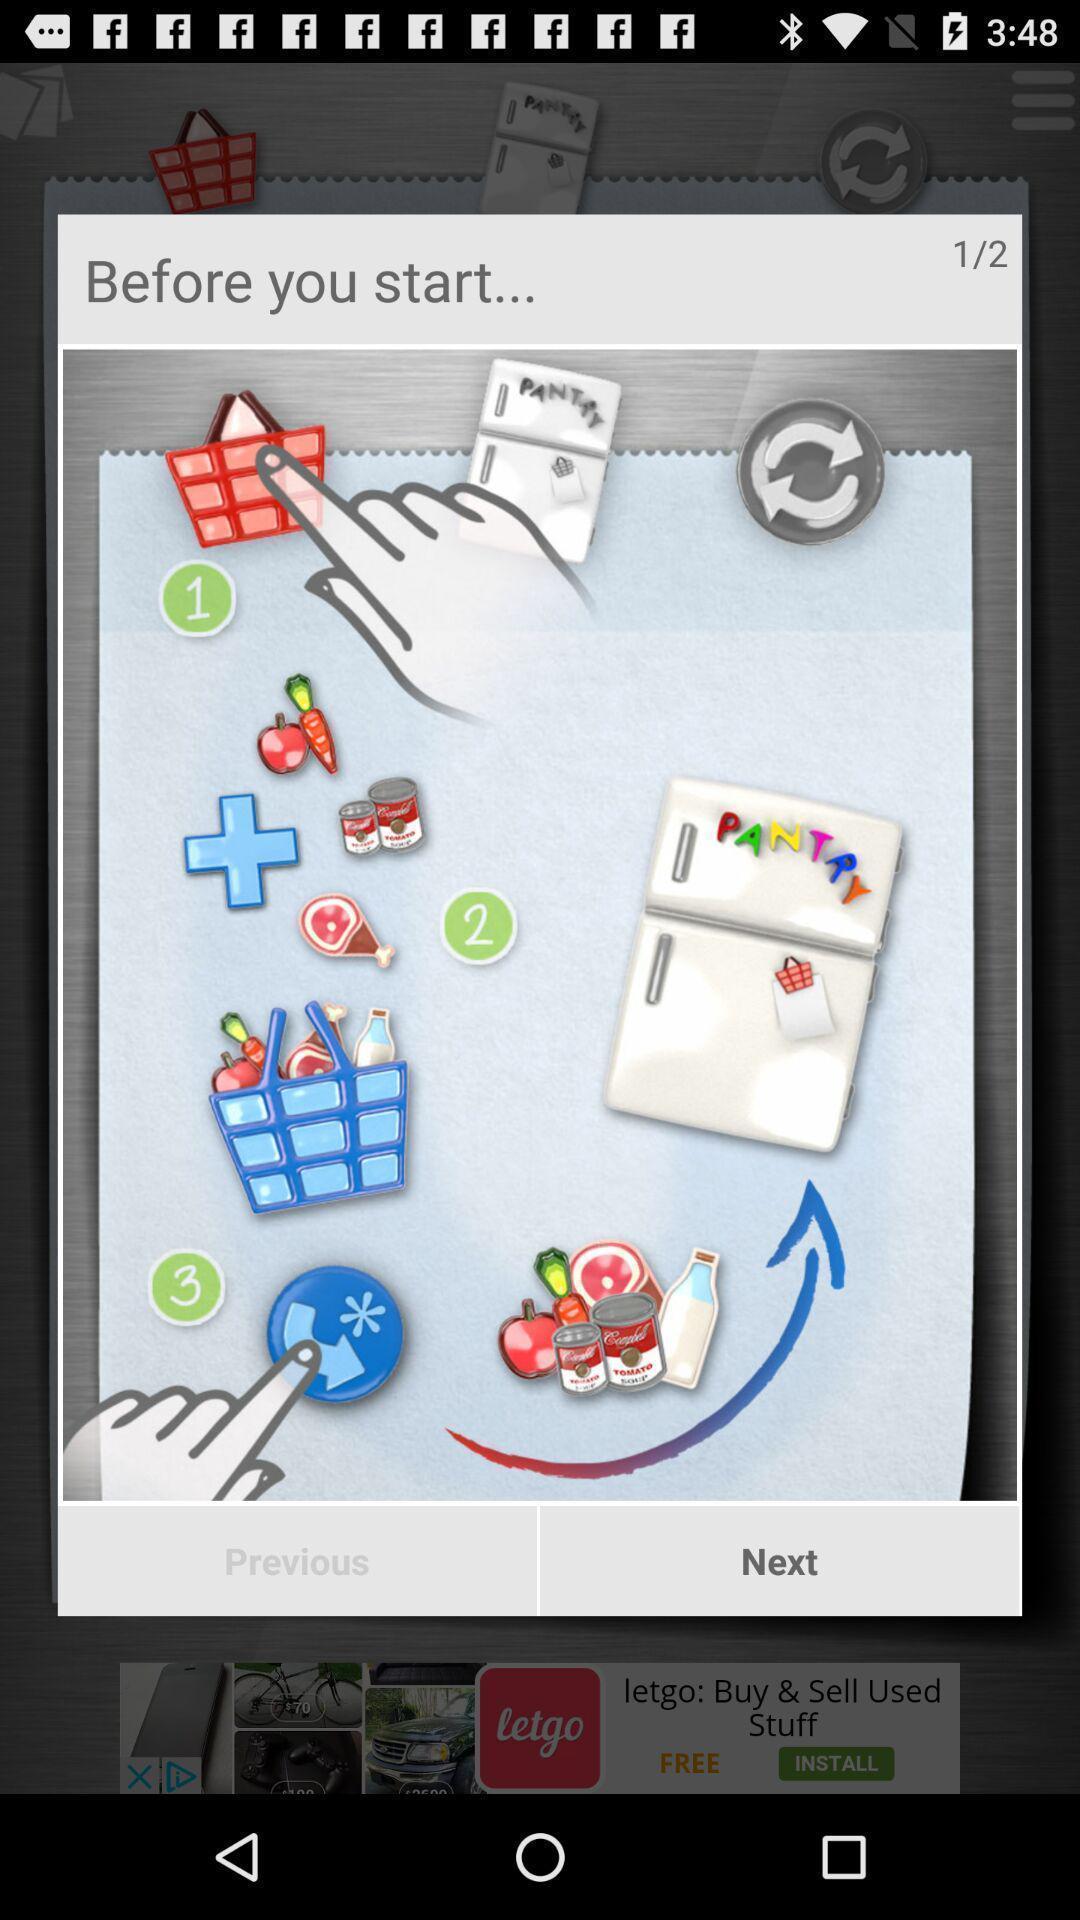Please provide a description for this image. Pop-up showing before you start option. 